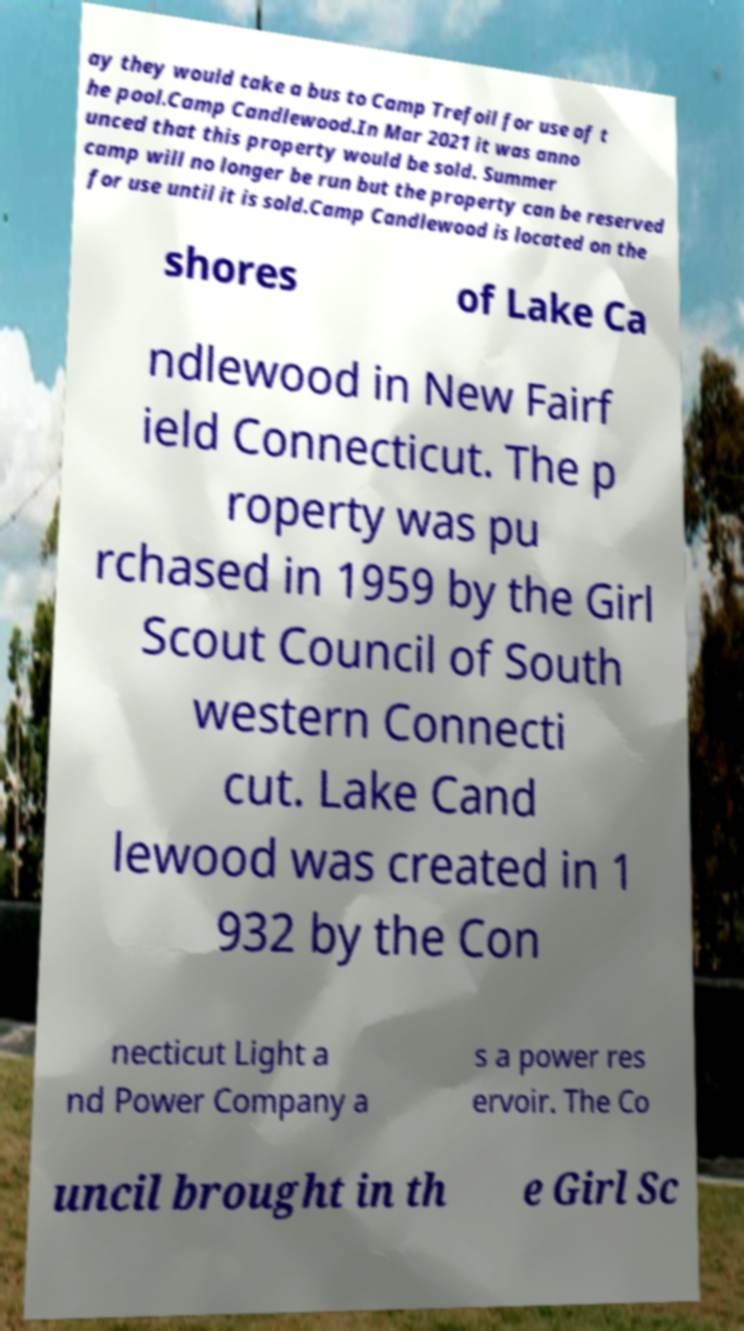There's text embedded in this image that I need extracted. Can you transcribe it verbatim? ay they would take a bus to Camp Trefoil for use of t he pool.Camp Candlewood.In Mar 2021 it was anno unced that this property would be sold. Summer camp will no longer be run but the property can be reserved for use until it is sold.Camp Candlewood is located on the shores of Lake Ca ndlewood in New Fairf ield Connecticut. The p roperty was pu rchased in 1959 by the Girl Scout Council of South western Connecti cut. Lake Cand lewood was created in 1 932 by the Con necticut Light a nd Power Company a s a power res ervoir. The Co uncil brought in th e Girl Sc 